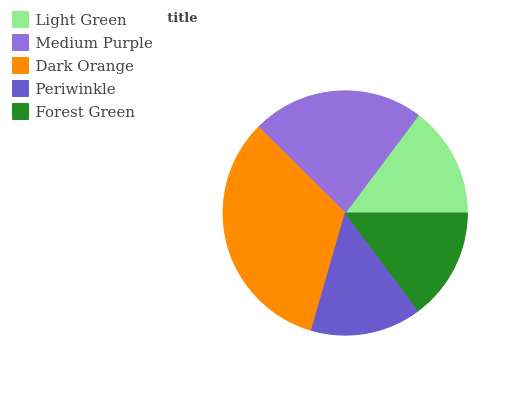Is Periwinkle the minimum?
Answer yes or no. Yes. Is Dark Orange the maximum?
Answer yes or no. Yes. Is Medium Purple the minimum?
Answer yes or no. No. Is Medium Purple the maximum?
Answer yes or no. No. Is Medium Purple greater than Light Green?
Answer yes or no. Yes. Is Light Green less than Medium Purple?
Answer yes or no. Yes. Is Light Green greater than Medium Purple?
Answer yes or no. No. Is Medium Purple less than Light Green?
Answer yes or no. No. Is Forest Green the high median?
Answer yes or no. Yes. Is Forest Green the low median?
Answer yes or no. Yes. Is Light Green the high median?
Answer yes or no. No. Is Dark Orange the low median?
Answer yes or no. No. 